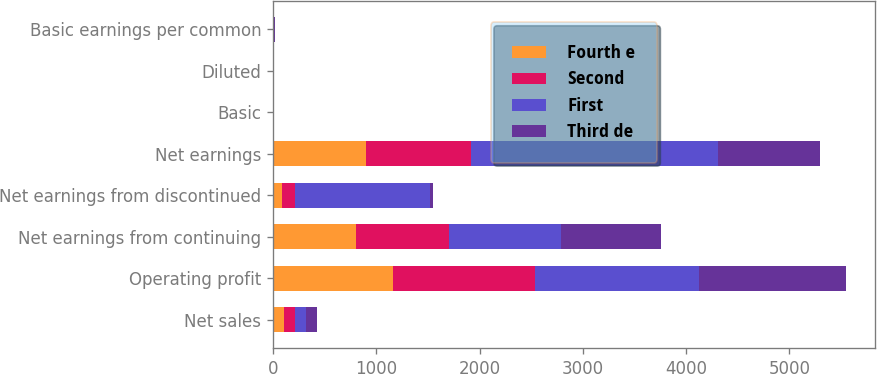Convert chart. <chart><loc_0><loc_0><loc_500><loc_500><stacked_bar_chart><ecel><fcel>Net sales<fcel>Operating profit<fcel>Net earnings from continuing<fcel>Net earnings from discontinued<fcel>Net earnings<fcel>Basic<fcel>Diluted<fcel>Basic earnings per common<nl><fcel>Fourth e<fcel>107<fcel>1158<fcel>806<fcel>92<fcel>898<fcel>2.65<fcel>2.61<fcel>2.95<nl><fcel>Second<fcel>107<fcel>1375<fcel>899<fcel>122<fcel>1021<fcel>2.97<fcel>2.93<fcel>3.37<nl><fcel>First<fcel>107<fcel>1588<fcel>1089<fcel>1306<fcel>2395<fcel>3.64<fcel>3.61<fcel>8.02<nl><fcel>Third de<fcel>107<fcel>1428<fcel>959<fcel>29<fcel>988<fcel>3.29<fcel>3.25<fcel>3.39<nl></chart> 